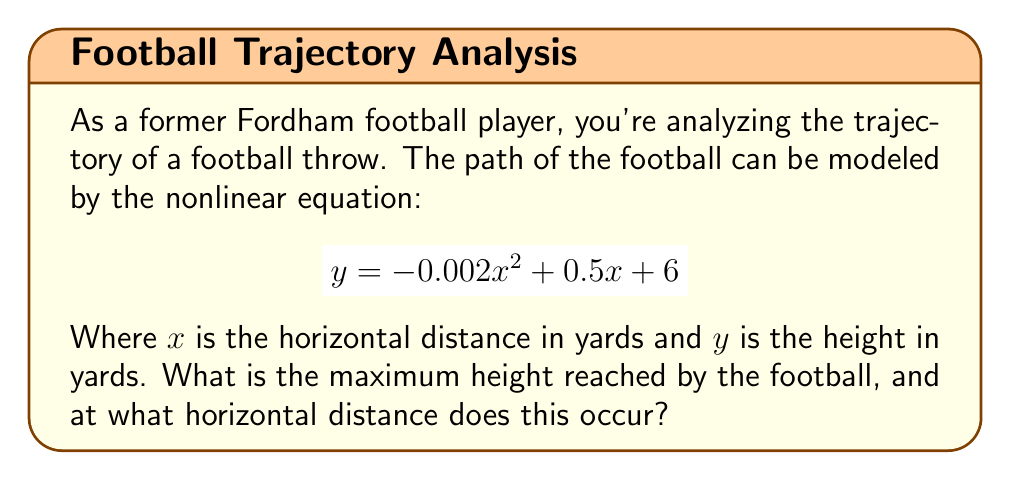Help me with this question. To solve this problem, we'll follow these steps:

1) The given equation represents a parabola: $y = -0.002x^2 + 0.5x + 6$

2) To find the maximum height, we need to find the vertex of this parabola. For a quadratic equation in the form $y = ax^2 + bx + c$, the x-coordinate of the vertex is given by $x = -\frac{b}{2a}$.

3) In our equation:
   $a = -0.002$
   $b = 0.5$
   $c = 6$

4) Calculating the x-coordinate of the vertex:
   $$x = -\frac{b}{2a} = -\frac{0.5}{2(-0.002)} = -\frac{0.5}{-0.004} = 125$$

5) To find the maximum height (y-coordinate of the vertex), we substitute this x-value back into the original equation:

   $$\begin{align}
   y &= -0.002(125)^2 + 0.5(125) + 6 \\
   &= -0.002(15625) + 62.5 + 6 \\
   &= -31.25 + 62.5 + 6 \\
   &= 37.25
   \end{align}$$

Therefore, the maximum height is 37.25 yards, occurring at a horizontal distance of 125 yards.
Answer: Maximum height: 37.25 yards; Horizontal distance: 125 yards 